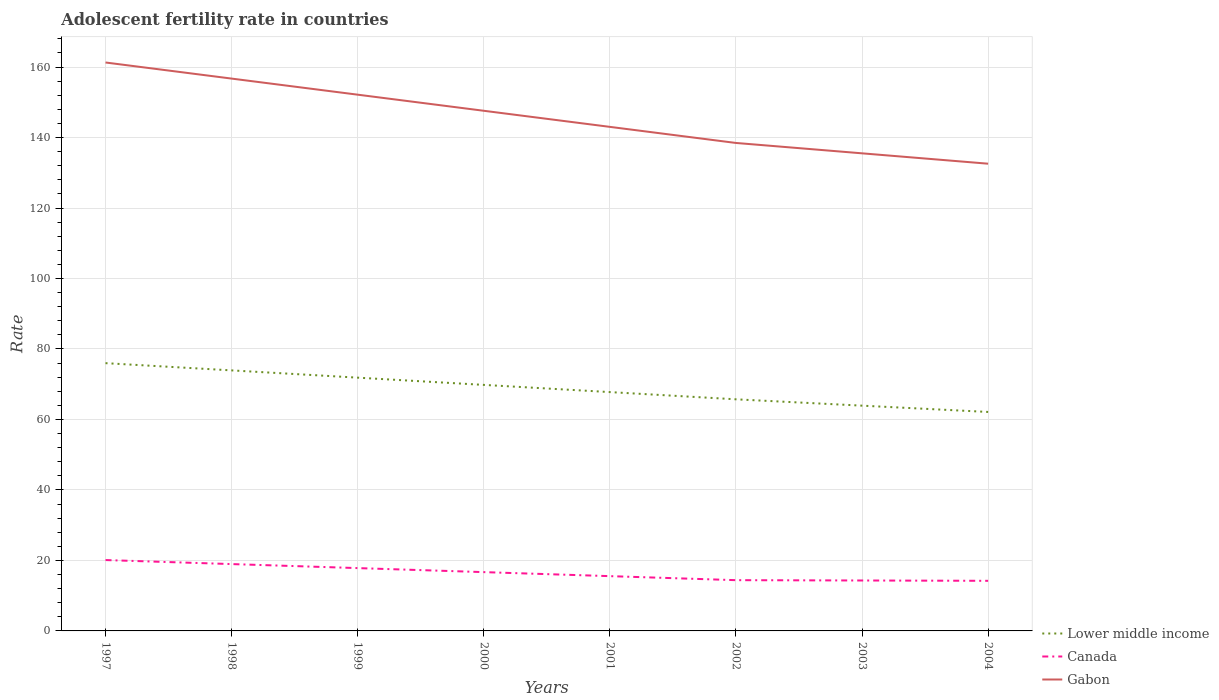Across all years, what is the maximum adolescent fertility rate in Gabon?
Keep it short and to the point. 132.57. In which year was the adolescent fertility rate in Canada maximum?
Give a very brief answer. 2004. What is the total adolescent fertility rate in Canada in the graph?
Keep it short and to the point. 3.42. What is the difference between the highest and the second highest adolescent fertility rate in Lower middle income?
Your answer should be compact. 13.85. What is the difference between the highest and the lowest adolescent fertility rate in Lower middle income?
Provide a succinct answer. 4. Is the adolescent fertility rate in Lower middle income strictly greater than the adolescent fertility rate in Gabon over the years?
Offer a very short reply. Yes. How many lines are there?
Give a very brief answer. 3. Are the values on the major ticks of Y-axis written in scientific E-notation?
Your answer should be very brief. No. Where does the legend appear in the graph?
Keep it short and to the point. Bottom right. How are the legend labels stacked?
Offer a very short reply. Vertical. What is the title of the graph?
Give a very brief answer. Adolescent fertility rate in countries. What is the label or title of the X-axis?
Your response must be concise. Years. What is the label or title of the Y-axis?
Provide a short and direct response. Rate. What is the Rate in Lower middle income in 1997?
Your answer should be very brief. 75.98. What is the Rate in Canada in 1997?
Your answer should be compact. 20.11. What is the Rate in Gabon in 1997?
Give a very brief answer. 161.29. What is the Rate of Lower middle income in 1998?
Your response must be concise. 73.93. What is the Rate in Canada in 1998?
Your answer should be compact. 18.97. What is the Rate in Gabon in 1998?
Offer a very short reply. 156.72. What is the Rate in Lower middle income in 1999?
Offer a terse response. 71.86. What is the Rate in Canada in 1999?
Make the answer very short. 17.83. What is the Rate of Gabon in 1999?
Your answer should be compact. 152.16. What is the Rate in Lower middle income in 2000?
Your answer should be compact. 69.81. What is the Rate of Canada in 2000?
Give a very brief answer. 16.68. What is the Rate in Gabon in 2000?
Offer a very short reply. 147.59. What is the Rate in Lower middle income in 2001?
Keep it short and to the point. 67.77. What is the Rate in Canada in 2001?
Provide a short and direct response. 15.54. What is the Rate of Gabon in 2001?
Offer a very short reply. 143.03. What is the Rate in Lower middle income in 2002?
Your response must be concise. 65.72. What is the Rate of Canada in 2002?
Give a very brief answer. 14.4. What is the Rate of Gabon in 2002?
Your answer should be very brief. 138.46. What is the Rate of Lower middle income in 2003?
Give a very brief answer. 63.92. What is the Rate of Canada in 2003?
Provide a succinct answer. 14.31. What is the Rate in Gabon in 2003?
Ensure brevity in your answer.  135.52. What is the Rate of Lower middle income in 2004?
Ensure brevity in your answer.  62.13. What is the Rate of Canada in 2004?
Keep it short and to the point. 14.22. What is the Rate in Gabon in 2004?
Offer a terse response. 132.57. Across all years, what is the maximum Rate of Lower middle income?
Your answer should be very brief. 75.98. Across all years, what is the maximum Rate in Canada?
Your answer should be very brief. 20.11. Across all years, what is the maximum Rate in Gabon?
Your response must be concise. 161.29. Across all years, what is the minimum Rate of Lower middle income?
Ensure brevity in your answer.  62.13. Across all years, what is the minimum Rate of Canada?
Keep it short and to the point. 14.22. Across all years, what is the minimum Rate of Gabon?
Give a very brief answer. 132.57. What is the total Rate of Lower middle income in the graph?
Make the answer very short. 551.12. What is the total Rate of Canada in the graph?
Your response must be concise. 132.06. What is the total Rate in Gabon in the graph?
Give a very brief answer. 1167.34. What is the difference between the Rate in Lower middle income in 1997 and that in 1998?
Give a very brief answer. 2.05. What is the difference between the Rate of Canada in 1997 and that in 1998?
Your answer should be compact. 1.14. What is the difference between the Rate in Gabon in 1997 and that in 1998?
Give a very brief answer. 4.57. What is the difference between the Rate of Lower middle income in 1997 and that in 1999?
Your answer should be compact. 4.11. What is the difference between the Rate of Canada in 1997 and that in 1999?
Give a very brief answer. 2.28. What is the difference between the Rate of Gabon in 1997 and that in 1999?
Offer a very short reply. 9.13. What is the difference between the Rate of Lower middle income in 1997 and that in 2000?
Offer a very short reply. 6.17. What is the difference between the Rate of Canada in 1997 and that in 2000?
Provide a succinct answer. 3.42. What is the difference between the Rate in Gabon in 1997 and that in 2000?
Your response must be concise. 13.7. What is the difference between the Rate in Lower middle income in 1997 and that in 2001?
Provide a short and direct response. 8.21. What is the difference between the Rate of Canada in 1997 and that in 2001?
Provide a short and direct response. 4.57. What is the difference between the Rate of Gabon in 1997 and that in 2001?
Give a very brief answer. 18.27. What is the difference between the Rate of Lower middle income in 1997 and that in 2002?
Give a very brief answer. 10.26. What is the difference between the Rate of Canada in 1997 and that in 2002?
Provide a short and direct response. 5.71. What is the difference between the Rate of Gabon in 1997 and that in 2002?
Provide a short and direct response. 22.83. What is the difference between the Rate of Lower middle income in 1997 and that in 2003?
Provide a short and direct response. 12.06. What is the difference between the Rate in Canada in 1997 and that in 2003?
Your answer should be compact. 5.8. What is the difference between the Rate of Gabon in 1997 and that in 2003?
Your response must be concise. 25.77. What is the difference between the Rate of Lower middle income in 1997 and that in 2004?
Provide a short and direct response. 13.85. What is the difference between the Rate of Canada in 1997 and that in 2004?
Make the answer very short. 5.89. What is the difference between the Rate of Gabon in 1997 and that in 2004?
Ensure brevity in your answer.  28.72. What is the difference between the Rate of Lower middle income in 1998 and that in 1999?
Your answer should be compact. 2.06. What is the difference between the Rate of Canada in 1998 and that in 1999?
Offer a very short reply. 1.14. What is the difference between the Rate of Gabon in 1998 and that in 1999?
Your answer should be very brief. 4.57. What is the difference between the Rate of Lower middle income in 1998 and that in 2000?
Your answer should be very brief. 4.11. What is the difference between the Rate of Canada in 1998 and that in 2000?
Ensure brevity in your answer.  2.28. What is the difference between the Rate in Gabon in 1998 and that in 2000?
Offer a terse response. 9.13. What is the difference between the Rate in Lower middle income in 1998 and that in 2001?
Offer a terse response. 6.16. What is the difference between the Rate of Canada in 1998 and that in 2001?
Your response must be concise. 3.42. What is the difference between the Rate in Gabon in 1998 and that in 2001?
Your response must be concise. 13.7. What is the difference between the Rate in Lower middle income in 1998 and that in 2002?
Offer a very short reply. 8.21. What is the difference between the Rate in Canada in 1998 and that in 2002?
Make the answer very short. 4.57. What is the difference between the Rate of Gabon in 1998 and that in 2002?
Your response must be concise. 18.27. What is the difference between the Rate of Lower middle income in 1998 and that in 2003?
Your response must be concise. 10.01. What is the difference between the Rate of Canada in 1998 and that in 2003?
Your answer should be compact. 4.66. What is the difference between the Rate of Gabon in 1998 and that in 2003?
Your response must be concise. 21.21. What is the difference between the Rate in Lower middle income in 1998 and that in 2004?
Your answer should be compact. 11.79. What is the difference between the Rate of Canada in 1998 and that in 2004?
Provide a succinct answer. 4.75. What is the difference between the Rate of Gabon in 1998 and that in 2004?
Offer a terse response. 24.15. What is the difference between the Rate in Lower middle income in 1999 and that in 2000?
Offer a terse response. 2.05. What is the difference between the Rate of Canada in 1999 and that in 2000?
Your answer should be compact. 1.14. What is the difference between the Rate in Gabon in 1999 and that in 2000?
Ensure brevity in your answer.  4.57. What is the difference between the Rate in Lower middle income in 1999 and that in 2001?
Keep it short and to the point. 4.1. What is the difference between the Rate of Canada in 1999 and that in 2001?
Keep it short and to the point. 2.28. What is the difference between the Rate of Gabon in 1999 and that in 2001?
Give a very brief answer. 9.13. What is the difference between the Rate in Lower middle income in 1999 and that in 2002?
Your answer should be compact. 6.15. What is the difference between the Rate of Canada in 1999 and that in 2002?
Your answer should be compact. 3.42. What is the difference between the Rate in Gabon in 1999 and that in 2002?
Ensure brevity in your answer.  13.7. What is the difference between the Rate in Lower middle income in 1999 and that in 2003?
Provide a short and direct response. 7.95. What is the difference between the Rate of Canada in 1999 and that in 2003?
Your answer should be very brief. 3.52. What is the difference between the Rate of Gabon in 1999 and that in 2003?
Provide a short and direct response. 16.64. What is the difference between the Rate in Lower middle income in 1999 and that in 2004?
Your answer should be compact. 9.73. What is the difference between the Rate of Canada in 1999 and that in 2004?
Provide a succinct answer. 3.61. What is the difference between the Rate of Gabon in 1999 and that in 2004?
Make the answer very short. 19.58. What is the difference between the Rate of Lower middle income in 2000 and that in 2001?
Keep it short and to the point. 2.04. What is the difference between the Rate in Canada in 2000 and that in 2001?
Make the answer very short. 1.14. What is the difference between the Rate in Gabon in 2000 and that in 2001?
Keep it short and to the point. 4.57. What is the difference between the Rate of Lower middle income in 2000 and that in 2002?
Keep it short and to the point. 4.09. What is the difference between the Rate in Canada in 2000 and that in 2002?
Your answer should be compact. 2.28. What is the difference between the Rate in Gabon in 2000 and that in 2002?
Provide a short and direct response. 9.13. What is the difference between the Rate of Lower middle income in 2000 and that in 2003?
Offer a terse response. 5.89. What is the difference between the Rate in Canada in 2000 and that in 2003?
Make the answer very short. 2.38. What is the difference between the Rate in Gabon in 2000 and that in 2003?
Give a very brief answer. 12.08. What is the difference between the Rate of Lower middle income in 2000 and that in 2004?
Keep it short and to the point. 7.68. What is the difference between the Rate of Canada in 2000 and that in 2004?
Provide a succinct answer. 2.47. What is the difference between the Rate of Gabon in 2000 and that in 2004?
Make the answer very short. 15.02. What is the difference between the Rate of Lower middle income in 2001 and that in 2002?
Ensure brevity in your answer.  2.05. What is the difference between the Rate in Canada in 2001 and that in 2002?
Your answer should be very brief. 1.14. What is the difference between the Rate in Gabon in 2001 and that in 2002?
Your response must be concise. 4.57. What is the difference between the Rate of Lower middle income in 2001 and that in 2003?
Keep it short and to the point. 3.85. What is the difference between the Rate of Canada in 2001 and that in 2003?
Make the answer very short. 1.23. What is the difference between the Rate of Gabon in 2001 and that in 2003?
Give a very brief answer. 7.51. What is the difference between the Rate of Lower middle income in 2001 and that in 2004?
Offer a very short reply. 5.64. What is the difference between the Rate of Canada in 2001 and that in 2004?
Give a very brief answer. 1.33. What is the difference between the Rate in Gabon in 2001 and that in 2004?
Provide a short and direct response. 10.45. What is the difference between the Rate in Lower middle income in 2002 and that in 2003?
Offer a terse response. 1.8. What is the difference between the Rate of Canada in 2002 and that in 2003?
Your response must be concise. 0.09. What is the difference between the Rate in Gabon in 2002 and that in 2003?
Ensure brevity in your answer.  2.94. What is the difference between the Rate in Lower middle income in 2002 and that in 2004?
Give a very brief answer. 3.59. What is the difference between the Rate in Canada in 2002 and that in 2004?
Give a very brief answer. 0.18. What is the difference between the Rate of Gabon in 2002 and that in 2004?
Your answer should be compact. 5.89. What is the difference between the Rate of Lower middle income in 2003 and that in 2004?
Ensure brevity in your answer.  1.79. What is the difference between the Rate in Canada in 2003 and that in 2004?
Make the answer very short. 0.09. What is the difference between the Rate in Gabon in 2003 and that in 2004?
Your answer should be very brief. 2.94. What is the difference between the Rate in Lower middle income in 1997 and the Rate in Canada in 1998?
Ensure brevity in your answer.  57.01. What is the difference between the Rate of Lower middle income in 1997 and the Rate of Gabon in 1998?
Provide a succinct answer. -80.75. What is the difference between the Rate in Canada in 1997 and the Rate in Gabon in 1998?
Make the answer very short. -136.62. What is the difference between the Rate in Lower middle income in 1997 and the Rate in Canada in 1999?
Offer a very short reply. 58.15. What is the difference between the Rate of Lower middle income in 1997 and the Rate of Gabon in 1999?
Your response must be concise. -76.18. What is the difference between the Rate of Canada in 1997 and the Rate of Gabon in 1999?
Your answer should be very brief. -132.05. What is the difference between the Rate in Lower middle income in 1997 and the Rate in Canada in 2000?
Your response must be concise. 59.29. What is the difference between the Rate of Lower middle income in 1997 and the Rate of Gabon in 2000?
Provide a succinct answer. -71.61. What is the difference between the Rate in Canada in 1997 and the Rate in Gabon in 2000?
Offer a very short reply. -127.48. What is the difference between the Rate in Lower middle income in 1997 and the Rate in Canada in 2001?
Make the answer very short. 60.44. What is the difference between the Rate in Lower middle income in 1997 and the Rate in Gabon in 2001?
Ensure brevity in your answer.  -67.05. What is the difference between the Rate in Canada in 1997 and the Rate in Gabon in 2001?
Provide a short and direct response. -122.92. What is the difference between the Rate of Lower middle income in 1997 and the Rate of Canada in 2002?
Give a very brief answer. 61.58. What is the difference between the Rate of Lower middle income in 1997 and the Rate of Gabon in 2002?
Your response must be concise. -62.48. What is the difference between the Rate of Canada in 1997 and the Rate of Gabon in 2002?
Provide a short and direct response. -118.35. What is the difference between the Rate in Lower middle income in 1997 and the Rate in Canada in 2003?
Provide a succinct answer. 61.67. What is the difference between the Rate in Lower middle income in 1997 and the Rate in Gabon in 2003?
Provide a short and direct response. -59.54. What is the difference between the Rate of Canada in 1997 and the Rate of Gabon in 2003?
Your answer should be compact. -115.41. What is the difference between the Rate in Lower middle income in 1997 and the Rate in Canada in 2004?
Provide a succinct answer. 61.76. What is the difference between the Rate of Lower middle income in 1997 and the Rate of Gabon in 2004?
Make the answer very short. -56.59. What is the difference between the Rate of Canada in 1997 and the Rate of Gabon in 2004?
Make the answer very short. -112.46. What is the difference between the Rate in Lower middle income in 1998 and the Rate in Canada in 1999?
Offer a terse response. 56.1. What is the difference between the Rate in Lower middle income in 1998 and the Rate in Gabon in 1999?
Provide a short and direct response. -78.23. What is the difference between the Rate in Canada in 1998 and the Rate in Gabon in 1999?
Ensure brevity in your answer.  -133.19. What is the difference between the Rate of Lower middle income in 1998 and the Rate of Canada in 2000?
Provide a succinct answer. 57.24. What is the difference between the Rate in Lower middle income in 1998 and the Rate in Gabon in 2000?
Offer a terse response. -73.67. What is the difference between the Rate of Canada in 1998 and the Rate of Gabon in 2000?
Your response must be concise. -128.62. What is the difference between the Rate in Lower middle income in 1998 and the Rate in Canada in 2001?
Make the answer very short. 58.38. What is the difference between the Rate in Lower middle income in 1998 and the Rate in Gabon in 2001?
Your response must be concise. -69.1. What is the difference between the Rate of Canada in 1998 and the Rate of Gabon in 2001?
Offer a terse response. -124.06. What is the difference between the Rate in Lower middle income in 1998 and the Rate in Canada in 2002?
Your answer should be very brief. 59.52. What is the difference between the Rate of Lower middle income in 1998 and the Rate of Gabon in 2002?
Offer a very short reply. -64.53. What is the difference between the Rate of Canada in 1998 and the Rate of Gabon in 2002?
Your answer should be compact. -119.49. What is the difference between the Rate in Lower middle income in 1998 and the Rate in Canada in 2003?
Ensure brevity in your answer.  59.62. What is the difference between the Rate of Lower middle income in 1998 and the Rate of Gabon in 2003?
Give a very brief answer. -61.59. What is the difference between the Rate in Canada in 1998 and the Rate in Gabon in 2003?
Keep it short and to the point. -116.55. What is the difference between the Rate in Lower middle income in 1998 and the Rate in Canada in 2004?
Provide a succinct answer. 59.71. What is the difference between the Rate in Lower middle income in 1998 and the Rate in Gabon in 2004?
Offer a very short reply. -58.65. What is the difference between the Rate of Canada in 1998 and the Rate of Gabon in 2004?
Provide a short and direct response. -113.61. What is the difference between the Rate in Lower middle income in 1999 and the Rate in Canada in 2000?
Ensure brevity in your answer.  55.18. What is the difference between the Rate of Lower middle income in 1999 and the Rate of Gabon in 2000?
Ensure brevity in your answer.  -75.73. What is the difference between the Rate in Canada in 1999 and the Rate in Gabon in 2000?
Provide a succinct answer. -129.77. What is the difference between the Rate of Lower middle income in 1999 and the Rate of Canada in 2001?
Your answer should be compact. 56.32. What is the difference between the Rate in Lower middle income in 1999 and the Rate in Gabon in 2001?
Offer a terse response. -71.16. What is the difference between the Rate of Canada in 1999 and the Rate of Gabon in 2001?
Your answer should be very brief. -125.2. What is the difference between the Rate in Lower middle income in 1999 and the Rate in Canada in 2002?
Offer a very short reply. 57.46. What is the difference between the Rate of Lower middle income in 1999 and the Rate of Gabon in 2002?
Provide a short and direct response. -66.59. What is the difference between the Rate of Canada in 1999 and the Rate of Gabon in 2002?
Provide a succinct answer. -120.63. What is the difference between the Rate in Lower middle income in 1999 and the Rate in Canada in 2003?
Provide a short and direct response. 57.55. What is the difference between the Rate of Lower middle income in 1999 and the Rate of Gabon in 2003?
Provide a succinct answer. -63.65. What is the difference between the Rate in Canada in 1999 and the Rate in Gabon in 2003?
Your response must be concise. -117.69. What is the difference between the Rate of Lower middle income in 1999 and the Rate of Canada in 2004?
Ensure brevity in your answer.  57.65. What is the difference between the Rate in Lower middle income in 1999 and the Rate in Gabon in 2004?
Ensure brevity in your answer.  -60.71. What is the difference between the Rate of Canada in 1999 and the Rate of Gabon in 2004?
Offer a very short reply. -114.75. What is the difference between the Rate of Lower middle income in 2000 and the Rate of Canada in 2001?
Offer a terse response. 54.27. What is the difference between the Rate of Lower middle income in 2000 and the Rate of Gabon in 2001?
Your answer should be compact. -73.21. What is the difference between the Rate of Canada in 2000 and the Rate of Gabon in 2001?
Your answer should be compact. -126.34. What is the difference between the Rate in Lower middle income in 2000 and the Rate in Canada in 2002?
Give a very brief answer. 55.41. What is the difference between the Rate in Lower middle income in 2000 and the Rate in Gabon in 2002?
Make the answer very short. -68.65. What is the difference between the Rate in Canada in 2000 and the Rate in Gabon in 2002?
Your answer should be very brief. -121.77. What is the difference between the Rate in Lower middle income in 2000 and the Rate in Canada in 2003?
Your answer should be very brief. 55.5. What is the difference between the Rate in Lower middle income in 2000 and the Rate in Gabon in 2003?
Provide a succinct answer. -65.7. What is the difference between the Rate in Canada in 2000 and the Rate in Gabon in 2003?
Offer a very short reply. -118.83. What is the difference between the Rate in Lower middle income in 2000 and the Rate in Canada in 2004?
Provide a short and direct response. 55.59. What is the difference between the Rate in Lower middle income in 2000 and the Rate in Gabon in 2004?
Provide a short and direct response. -62.76. What is the difference between the Rate in Canada in 2000 and the Rate in Gabon in 2004?
Keep it short and to the point. -115.89. What is the difference between the Rate of Lower middle income in 2001 and the Rate of Canada in 2002?
Offer a very short reply. 53.37. What is the difference between the Rate in Lower middle income in 2001 and the Rate in Gabon in 2002?
Provide a succinct answer. -70.69. What is the difference between the Rate in Canada in 2001 and the Rate in Gabon in 2002?
Offer a very short reply. -122.92. What is the difference between the Rate of Lower middle income in 2001 and the Rate of Canada in 2003?
Your answer should be very brief. 53.46. What is the difference between the Rate in Lower middle income in 2001 and the Rate in Gabon in 2003?
Ensure brevity in your answer.  -67.75. What is the difference between the Rate in Canada in 2001 and the Rate in Gabon in 2003?
Provide a short and direct response. -119.97. What is the difference between the Rate of Lower middle income in 2001 and the Rate of Canada in 2004?
Give a very brief answer. 53.55. What is the difference between the Rate of Lower middle income in 2001 and the Rate of Gabon in 2004?
Make the answer very short. -64.81. What is the difference between the Rate in Canada in 2001 and the Rate in Gabon in 2004?
Provide a short and direct response. -117.03. What is the difference between the Rate in Lower middle income in 2002 and the Rate in Canada in 2003?
Your response must be concise. 51.41. What is the difference between the Rate of Lower middle income in 2002 and the Rate of Gabon in 2003?
Offer a terse response. -69.8. What is the difference between the Rate in Canada in 2002 and the Rate in Gabon in 2003?
Keep it short and to the point. -121.11. What is the difference between the Rate in Lower middle income in 2002 and the Rate in Canada in 2004?
Ensure brevity in your answer.  51.5. What is the difference between the Rate of Lower middle income in 2002 and the Rate of Gabon in 2004?
Keep it short and to the point. -66.86. What is the difference between the Rate of Canada in 2002 and the Rate of Gabon in 2004?
Give a very brief answer. -118.17. What is the difference between the Rate of Lower middle income in 2003 and the Rate of Canada in 2004?
Offer a very short reply. 49.7. What is the difference between the Rate of Lower middle income in 2003 and the Rate of Gabon in 2004?
Your answer should be compact. -68.65. What is the difference between the Rate of Canada in 2003 and the Rate of Gabon in 2004?
Provide a succinct answer. -118.26. What is the average Rate in Lower middle income per year?
Provide a short and direct response. 68.89. What is the average Rate in Canada per year?
Your answer should be very brief. 16.51. What is the average Rate in Gabon per year?
Provide a short and direct response. 145.92. In the year 1997, what is the difference between the Rate of Lower middle income and Rate of Canada?
Your answer should be very brief. 55.87. In the year 1997, what is the difference between the Rate of Lower middle income and Rate of Gabon?
Provide a short and direct response. -85.31. In the year 1997, what is the difference between the Rate of Canada and Rate of Gabon?
Ensure brevity in your answer.  -141.18. In the year 1998, what is the difference between the Rate in Lower middle income and Rate in Canada?
Your answer should be compact. 54.96. In the year 1998, what is the difference between the Rate in Lower middle income and Rate in Gabon?
Offer a terse response. -82.8. In the year 1998, what is the difference between the Rate of Canada and Rate of Gabon?
Make the answer very short. -137.76. In the year 1999, what is the difference between the Rate in Lower middle income and Rate in Canada?
Give a very brief answer. 54.04. In the year 1999, what is the difference between the Rate of Lower middle income and Rate of Gabon?
Your answer should be very brief. -80.29. In the year 1999, what is the difference between the Rate of Canada and Rate of Gabon?
Provide a short and direct response. -134.33. In the year 2000, what is the difference between the Rate in Lower middle income and Rate in Canada?
Provide a succinct answer. 53.13. In the year 2000, what is the difference between the Rate in Lower middle income and Rate in Gabon?
Keep it short and to the point. -77.78. In the year 2000, what is the difference between the Rate of Canada and Rate of Gabon?
Make the answer very short. -130.91. In the year 2001, what is the difference between the Rate of Lower middle income and Rate of Canada?
Ensure brevity in your answer.  52.22. In the year 2001, what is the difference between the Rate of Lower middle income and Rate of Gabon?
Your response must be concise. -75.26. In the year 2001, what is the difference between the Rate in Canada and Rate in Gabon?
Offer a very short reply. -127.48. In the year 2002, what is the difference between the Rate in Lower middle income and Rate in Canada?
Offer a very short reply. 51.32. In the year 2002, what is the difference between the Rate in Lower middle income and Rate in Gabon?
Offer a very short reply. -72.74. In the year 2002, what is the difference between the Rate of Canada and Rate of Gabon?
Your answer should be very brief. -124.06. In the year 2003, what is the difference between the Rate of Lower middle income and Rate of Canada?
Your answer should be compact. 49.61. In the year 2003, what is the difference between the Rate of Lower middle income and Rate of Gabon?
Offer a very short reply. -71.6. In the year 2003, what is the difference between the Rate of Canada and Rate of Gabon?
Make the answer very short. -121.21. In the year 2004, what is the difference between the Rate of Lower middle income and Rate of Canada?
Your answer should be compact. 47.91. In the year 2004, what is the difference between the Rate of Lower middle income and Rate of Gabon?
Provide a short and direct response. -70.44. In the year 2004, what is the difference between the Rate in Canada and Rate in Gabon?
Your answer should be very brief. -118.36. What is the ratio of the Rate of Lower middle income in 1997 to that in 1998?
Provide a short and direct response. 1.03. What is the ratio of the Rate in Canada in 1997 to that in 1998?
Ensure brevity in your answer.  1.06. What is the ratio of the Rate of Gabon in 1997 to that in 1998?
Keep it short and to the point. 1.03. What is the ratio of the Rate of Lower middle income in 1997 to that in 1999?
Offer a terse response. 1.06. What is the ratio of the Rate in Canada in 1997 to that in 1999?
Ensure brevity in your answer.  1.13. What is the ratio of the Rate in Gabon in 1997 to that in 1999?
Provide a succinct answer. 1.06. What is the ratio of the Rate in Lower middle income in 1997 to that in 2000?
Provide a short and direct response. 1.09. What is the ratio of the Rate of Canada in 1997 to that in 2000?
Provide a short and direct response. 1.21. What is the ratio of the Rate of Gabon in 1997 to that in 2000?
Offer a terse response. 1.09. What is the ratio of the Rate in Lower middle income in 1997 to that in 2001?
Give a very brief answer. 1.12. What is the ratio of the Rate of Canada in 1997 to that in 2001?
Offer a very short reply. 1.29. What is the ratio of the Rate of Gabon in 1997 to that in 2001?
Keep it short and to the point. 1.13. What is the ratio of the Rate in Lower middle income in 1997 to that in 2002?
Ensure brevity in your answer.  1.16. What is the ratio of the Rate in Canada in 1997 to that in 2002?
Your answer should be compact. 1.4. What is the ratio of the Rate in Gabon in 1997 to that in 2002?
Provide a succinct answer. 1.16. What is the ratio of the Rate of Lower middle income in 1997 to that in 2003?
Provide a succinct answer. 1.19. What is the ratio of the Rate in Canada in 1997 to that in 2003?
Your answer should be very brief. 1.41. What is the ratio of the Rate of Gabon in 1997 to that in 2003?
Your response must be concise. 1.19. What is the ratio of the Rate in Lower middle income in 1997 to that in 2004?
Keep it short and to the point. 1.22. What is the ratio of the Rate in Canada in 1997 to that in 2004?
Make the answer very short. 1.41. What is the ratio of the Rate of Gabon in 1997 to that in 2004?
Ensure brevity in your answer.  1.22. What is the ratio of the Rate of Lower middle income in 1998 to that in 1999?
Your response must be concise. 1.03. What is the ratio of the Rate of Canada in 1998 to that in 1999?
Offer a very short reply. 1.06. What is the ratio of the Rate of Lower middle income in 1998 to that in 2000?
Provide a succinct answer. 1.06. What is the ratio of the Rate in Canada in 1998 to that in 2000?
Give a very brief answer. 1.14. What is the ratio of the Rate of Gabon in 1998 to that in 2000?
Give a very brief answer. 1.06. What is the ratio of the Rate in Canada in 1998 to that in 2001?
Provide a short and direct response. 1.22. What is the ratio of the Rate of Gabon in 1998 to that in 2001?
Give a very brief answer. 1.1. What is the ratio of the Rate of Lower middle income in 1998 to that in 2002?
Ensure brevity in your answer.  1.12. What is the ratio of the Rate of Canada in 1998 to that in 2002?
Your answer should be very brief. 1.32. What is the ratio of the Rate in Gabon in 1998 to that in 2002?
Offer a very short reply. 1.13. What is the ratio of the Rate in Lower middle income in 1998 to that in 2003?
Offer a terse response. 1.16. What is the ratio of the Rate in Canada in 1998 to that in 2003?
Offer a terse response. 1.33. What is the ratio of the Rate in Gabon in 1998 to that in 2003?
Give a very brief answer. 1.16. What is the ratio of the Rate in Lower middle income in 1998 to that in 2004?
Ensure brevity in your answer.  1.19. What is the ratio of the Rate in Canada in 1998 to that in 2004?
Make the answer very short. 1.33. What is the ratio of the Rate in Gabon in 1998 to that in 2004?
Offer a very short reply. 1.18. What is the ratio of the Rate in Lower middle income in 1999 to that in 2000?
Make the answer very short. 1.03. What is the ratio of the Rate in Canada in 1999 to that in 2000?
Give a very brief answer. 1.07. What is the ratio of the Rate in Gabon in 1999 to that in 2000?
Offer a terse response. 1.03. What is the ratio of the Rate of Lower middle income in 1999 to that in 2001?
Provide a succinct answer. 1.06. What is the ratio of the Rate of Canada in 1999 to that in 2001?
Ensure brevity in your answer.  1.15. What is the ratio of the Rate of Gabon in 1999 to that in 2001?
Your answer should be very brief. 1.06. What is the ratio of the Rate in Lower middle income in 1999 to that in 2002?
Ensure brevity in your answer.  1.09. What is the ratio of the Rate in Canada in 1999 to that in 2002?
Your answer should be compact. 1.24. What is the ratio of the Rate of Gabon in 1999 to that in 2002?
Ensure brevity in your answer.  1.1. What is the ratio of the Rate in Lower middle income in 1999 to that in 2003?
Make the answer very short. 1.12. What is the ratio of the Rate of Canada in 1999 to that in 2003?
Your answer should be compact. 1.25. What is the ratio of the Rate in Gabon in 1999 to that in 2003?
Keep it short and to the point. 1.12. What is the ratio of the Rate in Lower middle income in 1999 to that in 2004?
Make the answer very short. 1.16. What is the ratio of the Rate of Canada in 1999 to that in 2004?
Your response must be concise. 1.25. What is the ratio of the Rate in Gabon in 1999 to that in 2004?
Provide a short and direct response. 1.15. What is the ratio of the Rate of Lower middle income in 2000 to that in 2001?
Give a very brief answer. 1.03. What is the ratio of the Rate of Canada in 2000 to that in 2001?
Your response must be concise. 1.07. What is the ratio of the Rate in Gabon in 2000 to that in 2001?
Your response must be concise. 1.03. What is the ratio of the Rate of Lower middle income in 2000 to that in 2002?
Give a very brief answer. 1.06. What is the ratio of the Rate of Canada in 2000 to that in 2002?
Your response must be concise. 1.16. What is the ratio of the Rate in Gabon in 2000 to that in 2002?
Make the answer very short. 1.07. What is the ratio of the Rate in Lower middle income in 2000 to that in 2003?
Offer a terse response. 1.09. What is the ratio of the Rate in Canada in 2000 to that in 2003?
Provide a short and direct response. 1.17. What is the ratio of the Rate of Gabon in 2000 to that in 2003?
Make the answer very short. 1.09. What is the ratio of the Rate of Lower middle income in 2000 to that in 2004?
Offer a terse response. 1.12. What is the ratio of the Rate in Canada in 2000 to that in 2004?
Your response must be concise. 1.17. What is the ratio of the Rate of Gabon in 2000 to that in 2004?
Your answer should be compact. 1.11. What is the ratio of the Rate of Lower middle income in 2001 to that in 2002?
Give a very brief answer. 1.03. What is the ratio of the Rate in Canada in 2001 to that in 2002?
Provide a short and direct response. 1.08. What is the ratio of the Rate in Gabon in 2001 to that in 2002?
Provide a short and direct response. 1.03. What is the ratio of the Rate of Lower middle income in 2001 to that in 2003?
Provide a short and direct response. 1.06. What is the ratio of the Rate of Canada in 2001 to that in 2003?
Your answer should be compact. 1.09. What is the ratio of the Rate in Gabon in 2001 to that in 2003?
Ensure brevity in your answer.  1.06. What is the ratio of the Rate in Lower middle income in 2001 to that in 2004?
Offer a terse response. 1.09. What is the ratio of the Rate in Canada in 2001 to that in 2004?
Provide a short and direct response. 1.09. What is the ratio of the Rate of Gabon in 2001 to that in 2004?
Give a very brief answer. 1.08. What is the ratio of the Rate in Lower middle income in 2002 to that in 2003?
Offer a terse response. 1.03. What is the ratio of the Rate in Canada in 2002 to that in 2003?
Ensure brevity in your answer.  1.01. What is the ratio of the Rate in Gabon in 2002 to that in 2003?
Provide a short and direct response. 1.02. What is the ratio of the Rate of Lower middle income in 2002 to that in 2004?
Ensure brevity in your answer.  1.06. What is the ratio of the Rate in Canada in 2002 to that in 2004?
Your answer should be very brief. 1.01. What is the ratio of the Rate in Gabon in 2002 to that in 2004?
Your answer should be very brief. 1.04. What is the ratio of the Rate of Lower middle income in 2003 to that in 2004?
Make the answer very short. 1.03. What is the ratio of the Rate in Gabon in 2003 to that in 2004?
Your response must be concise. 1.02. What is the difference between the highest and the second highest Rate of Lower middle income?
Keep it short and to the point. 2.05. What is the difference between the highest and the second highest Rate of Canada?
Give a very brief answer. 1.14. What is the difference between the highest and the second highest Rate in Gabon?
Keep it short and to the point. 4.57. What is the difference between the highest and the lowest Rate in Lower middle income?
Give a very brief answer. 13.85. What is the difference between the highest and the lowest Rate of Canada?
Your answer should be very brief. 5.89. What is the difference between the highest and the lowest Rate of Gabon?
Offer a very short reply. 28.72. 